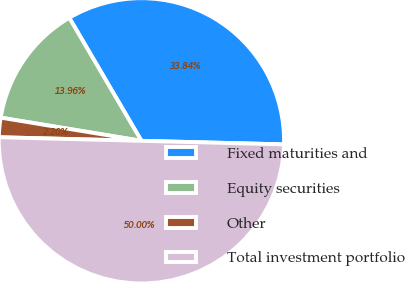<chart> <loc_0><loc_0><loc_500><loc_500><pie_chart><fcel>Fixed maturities and<fcel>Equity securities<fcel>Other<fcel>Total investment portfolio<nl><fcel>33.84%<fcel>13.96%<fcel>2.2%<fcel>50.0%<nl></chart> 